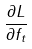<formula> <loc_0><loc_0><loc_500><loc_500>\frac { \partial L } { \partial f _ { t } }</formula> 